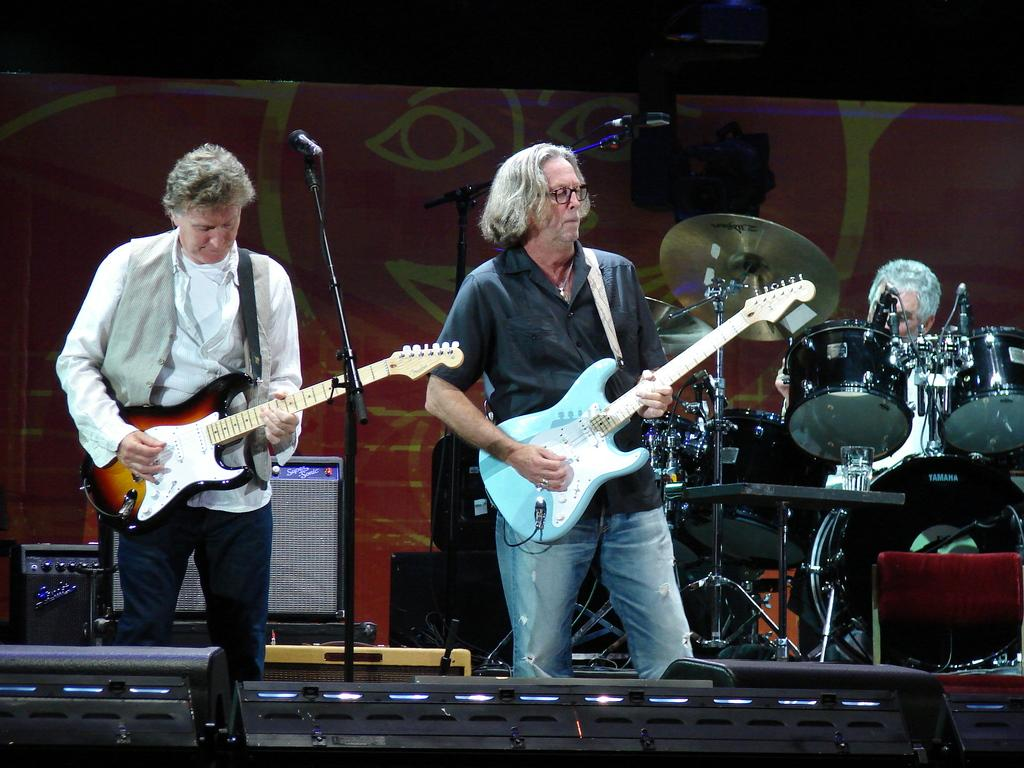How many people are in the image? There are two people in the image. What are the two people doing in the image? The two people are playing guitar. What object is placed in front of them? There is a microphone placed before them. What can be seen in the background of the image? There is a band and a board in the background of the image. What sense does the board in the background of the image appeal to? The board in the background of the image does not appeal to any sense, as it is a static object in the image. 